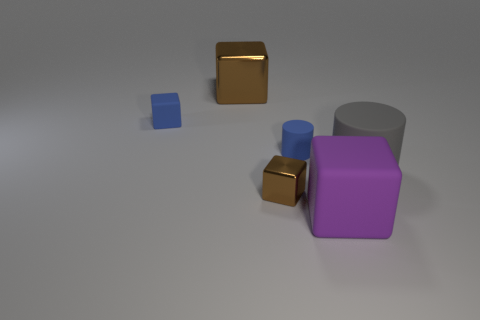Do the big metallic cube and the small metallic object have the same color?
Offer a terse response. Yes. Do the matte cylinder that is on the left side of the big gray rubber cylinder and the small matte cube have the same color?
Provide a succinct answer. Yes. What number of cubes have the same color as the large metal thing?
Offer a terse response. 1. What number of blocks are there?
Offer a very short reply. 4. How many small brown objects have the same material as the gray thing?
Your response must be concise. 0. What size is the other matte thing that is the same shape as the big purple object?
Make the answer very short. Small. What is the material of the blue cube?
Offer a terse response. Rubber. There is a object behind the object left of the metal object that is behind the tiny blue cylinder; what is it made of?
Ensure brevity in your answer.  Metal. What is the color of the other thing that is the same shape as the gray thing?
Make the answer very short. Blue. Does the matte block behind the small metal object have the same color as the small object that is right of the tiny brown thing?
Keep it short and to the point. Yes. 